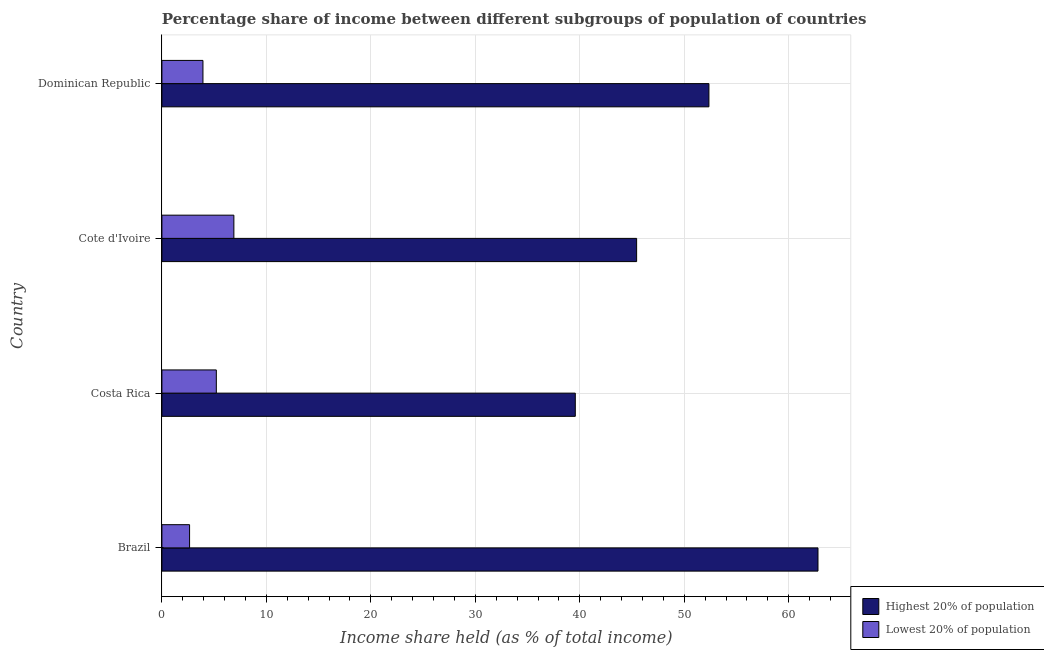Are the number of bars on each tick of the Y-axis equal?
Offer a very short reply. Yes. How many bars are there on the 3rd tick from the top?
Your answer should be very brief. 2. What is the label of the 4th group of bars from the top?
Give a very brief answer. Brazil. What is the income share held by highest 20% of the population in Dominican Republic?
Your answer should be very brief. 52.36. Across all countries, what is the maximum income share held by highest 20% of the population?
Make the answer very short. 62.8. Across all countries, what is the minimum income share held by lowest 20% of the population?
Provide a short and direct response. 2.65. In which country was the income share held by lowest 20% of the population maximum?
Offer a very short reply. Cote d'Ivoire. In which country was the income share held by highest 20% of the population minimum?
Your answer should be compact. Costa Rica. What is the total income share held by highest 20% of the population in the graph?
Your response must be concise. 200.17. What is the difference between the income share held by highest 20% of the population in Cote d'Ivoire and that in Dominican Republic?
Give a very brief answer. -6.92. What is the difference between the income share held by highest 20% of the population in Costa Rica and the income share held by lowest 20% of the population in Cote d'Ivoire?
Your answer should be compact. 32.68. What is the average income share held by highest 20% of the population per country?
Your answer should be compact. 50.04. What is the difference between the income share held by lowest 20% of the population and income share held by highest 20% of the population in Dominican Republic?
Give a very brief answer. -48.43. In how many countries, is the income share held by lowest 20% of the population greater than 34 %?
Your answer should be compact. 0. What is the ratio of the income share held by highest 20% of the population in Brazil to that in Costa Rica?
Your answer should be very brief. 1.59. What is the difference between the highest and the second highest income share held by highest 20% of the population?
Offer a very short reply. 10.44. What is the difference between the highest and the lowest income share held by lowest 20% of the population?
Provide a short and direct response. 4.24. Is the sum of the income share held by highest 20% of the population in Brazil and Costa Rica greater than the maximum income share held by lowest 20% of the population across all countries?
Give a very brief answer. Yes. What does the 1st bar from the top in Cote d'Ivoire represents?
Offer a terse response. Lowest 20% of population. What does the 1st bar from the bottom in Costa Rica represents?
Ensure brevity in your answer.  Highest 20% of population. How many bars are there?
Make the answer very short. 8. Are all the bars in the graph horizontal?
Give a very brief answer. Yes. How many countries are there in the graph?
Ensure brevity in your answer.  4. What is the difference between two consecutive major ticks on the X-axis?
Ensure brevity in your answer.  10. Are the values on the major ticks of X-axis written in scientific E-notation?
Provide a short and direct response. No. Does the graph contain grids?
Give a very brief answer. Yes. Where does the legend appear in the graph?
Your answer should be very brief. Bottom right. What is the title of the graph?
Provide a succinct answer. Percentage share of income between different subgroups of population of countries. Does "From production" appear as one of the legend labels in the graph?
Make the answer very short. No. What is the label or title of the X-axis?
Give a very brief answer. Income share held (as % of total income). What is the Income share held (as % of total income) in Highest 20% of population in Brazil?
Make the answer very short. 62.8. What is the Income share held (as % of total income) in Lowest 20% of population in Brazil?
Ensure brevity in your answer.  2.65. What is the Income share held (as % of total income) of Highest 20% of population in Costa Rica?
Offer a very short reply. 39.57. What is the Income share held (as % of total income) in Lowest 20% of population in Costa Rica?
Offer a terse response. 5.21. What is the Income share held (as % of total income) of Highest 20% of population in Cote d'Ivoire?
Ensure brevity in your answer.  45.44. What is the Income share held (as % of total income) of Lowest 20% of population in Cote d'Ivoire?
Offer a terse response. 6.89. What is the Income share held (as % of total income) of Highest 20% of population in Dominican Republic?
Keep it short and to the point. 52.36. What is the Income share held (as % of total income) in Lowest 20% of population in Dominican Republic?
Make the answer very short. 3.93. Across all countries, what is the maximum Income share held (as % of total income) of Highest 20% of population?
Offer a very short reply. 62.8. Across all countries, what is the maximum Income share held (as % of total income) in Lowest 20% of population?
Provide a succinct answer. 6.89. Across all countries, what is the minimum Income share held (as % of total income) in Highest 20% of population?
Ensure brevity in your answer.  39.57. Across all countries, what is the minimum Income share held (as % of total income) in Lowest 20% of population?
Your response must be concise. 2.65. What is the total Income share held (as % of total income) of Highest 20% of population in the graph?
Offer a terse response. 200.17. What is the total Income share held (as % of total income) of Lowest 20% of population in the graph?
Ensure brevity in your answer.  18.68. What is the difference between the Income share held (as % of total income) in Highest 20% of population in Brazil and that in Costa Rica?
Your response must be concise. 23.23. What is the difference between the Income share held (as % of total income) of Lowest 20% of population in Brazil and that in Costa Rica?
Your answer should be very brief. -2.56. What is the difference between the Income share held (as % of total income) of Highest 20% of population in Brazil and that in Cote d'Ivoire?
Make the answer very short. 17.36. What is the difference between the Income share held (as % of total income) in Lowest 20% of population in Brazil and that in Cote d'Ivoire?
Ensure brevity in your answer.  -4.24. What is the difference between the Income share held (as % of total income) in Highest 20% of population in Brazil and that in Dominican Republic?
Your answer should be very brief. 10.44. What is the difference between the Income share held (as % of total income) in Lowest 20% of population in Brazil and that in Dominican Republic?
Offer a terse response. -1.28. What is the difference between the Income share held (as % of total income) in Highest 20% of population in Costa Rica and that in Cote d'Ivoire?
Your response must be concise. -5.87. What is the difference between the Income share held (as % of total income) in Lowest 20% of population in Costa Rica and that in Cote d'Ivoire?
Provide a short and direct response. -1.68. What is the difference between the Income share held (as % of total income) of Highest 20% of population in Costa Rica and that in Dominican Republic?
Your answer should be compact. -12.79. What is the difference between the Income share held (as % of total income) in Lowest 20% of population in Costa Rica and that in Dominican Republic?
Your answer should be very brief. 1.28. What is the difference between the Income share held (as % of total income) of Highest 20% of population in Cote d'Ivoire and that in Dominican Republic?
Keep it short and to the point. -6.92. What is the difference between the Income share held (as % of total income) of Lowest 20% of population in Cote d'Ivoire and that in Dominican Republic?
Provide a succinct answer. 2.96. What is the difference between the Income share held (as % of total income) of Highest 20% of population in Brazil and the Income share held (as % of total income) of Lowest 20% of population in Costa Rica?
Provide a succinct answer. 57.59. What is the difference between the Income share held (as % of total income) of Highest 20% of population in Brazil and the Income share held (as % of total income) of Lowest 20% of population in Cote d'Ivoire?
Ensure brevity in your answer.  55.91. What is the difference between the Income share held (as % of total income) in Highest 20% of population in Brazil and the Income share held (as % of total income) in Lowest 20% of population in Dominican Republic?
Give a very brief answer. 58.87. What is the difference between the Income share held (as % of total income) of Highest 20% of population in Costa Rica and the Income share held (as % of total income) of Lowest 20% of population in Cote d'Ivoire?
Your answer should be very brief. 32.68. What is the difference between the Income share held (as % of total income) of Highest 20% of population in Costa Rica and the Income share held (as % of total income) of Lowest 20% of population in Dominican Republic?
Your answer should be compact. 35.64. What is the difference between the Income share held (as % of total income) in Highest 20% of population in Cote d'Ivoire and the Income share held (as % of total income) in Lowest 20% of population in Dominican Republic?
Make the answer very short. 41.51. What is the average Income share held (as % of total income) of Highest 20% of population per country?
Provide a succinct answer. 50.04. What is the average Income share held (as % of total income) of Lowest 20% of population per country?
Provide a short and direct response. 4.67. What is the difference between the Income share held (as % of total income) in Highest 20% of population and Income share held (as % of total income) in Lowest 20% of population in Brazil?
Your answer should be very brief. 60.15. What is the difference between the Income share held (as % of total income) in Highest 20% of population and Income share held (as % of total income) in Lowest 20% of population in Costa Rica?
Provide a succinct answer. 34.36. What is the difference between the Income share held (as % of total income) in Highest 20% of population and Income share held (as % of total income) in Lowest 20% of population in Cote d'Ivoire?
Ensure brevity in your answer.  38.55. What is the difference between the Income share held (as % of total income) in Highest 20% of population and Income share held (as % of total income) in Lowest 20% of population in Dominican Republic?
Offer a very short reply. 48.43. What is the ratio of the Income share held (as % of total income) of Highest 20% of population in Brazil to that in Costa Rica?
Your answer should be compact. 1.59. What is the ratio of the Income share held (as % of total income) in Lowest 20% of population in Brazil to that in Costa Rica?
Offer a very short reply. 0.51. What is the ratio of the Income share held (as % of total income) in Highest 20% of population in Brazil to that in Cote d'Ivoire?
Ensure brevity in your answer.  1.38. What is the ratio of the Income share held (as % of total income) of Lowest 20% of population in Brazil to that in Cote d'Ivoire?
Your response must be concise. 0.38. What is the ratio of the Income share held (as % of total income) of Highest 20% of population in Brazil to that in Dominican Republic?
Give a very brief answer. 1.2. What is the ratio of the Income share held (as % of total income) of Lowest 20% of population in Brazil to that in Dominican Republic?
Make the answer very short. 0.67. What is the ratio of the Income share held (as % of total income) in Highest 20% of population in Costa Rica to that in Cote d'Ivoire?
Provide a short and direct response. 0.87. What is the ratio of the Income share held (as % of total income) in Lowest 20% of population in Costa Rica to that in Cote d'Ivoire?
Offer a terse response. 0.76. What is the ratio of the Income share held (as % of total income) of Highest 20% of population in Costa Rica to that in Dominican Republic?
Make the answer very short. 0.76. What is the ratio of the Income share held (as % of total income) in Lowest 20% of population in Costa Rica to that in Dominican Republic?
Give a very brief answer. 1.33. What is the ratio of the Income share held (as % of total income) of Highest 20% of population in Cote d'Ivoire to that in Dominican Republic?
Provide a succinct answer. 0.87. What is the ratio of the Income share held (as % of total income) in Lowest 20% of population in Cote d'Ivoire to that in Dominican Republic?
Provide a succinct answer. 1.75. What is the difference between the highest and the second highest Income share held (as % of total income) in Highest 20% of population?
Your answer should be compact. 10.44. What is the difference between the highest and the second highest Income share held (as % of total income) in Lowest 20% of population?
Offer a very short reply. 1.68. What is the difference between the highest and the lowest Income share held (as % of total income) of Highest 20% of population?
Ensure brevity in your answer.  23.23. What is the difference between the highest and the lowest Income share held (as % of total income) of Lowest 20% of population?
Make the answer very short. 4.24. 